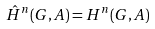<formula> <loc_0><loc_0><loc_500><loc_500>\hat { H } ^ { n } ( G , A ) = H ^ { n } ( G , A )</formula> 